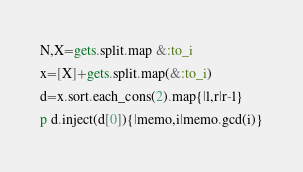Convert code to text. <code><loc_0><loc_0><loc_500><loc_500><_Ruby_>N,X=gets.split.map &:to_i
x=[X]+gets.split.map(&:to_i)
d=x.sort.each_cons(2).map{|l,r|r-l}
p d.inject(d[0]){|memo,i|memo.gcd(i)}</code> 